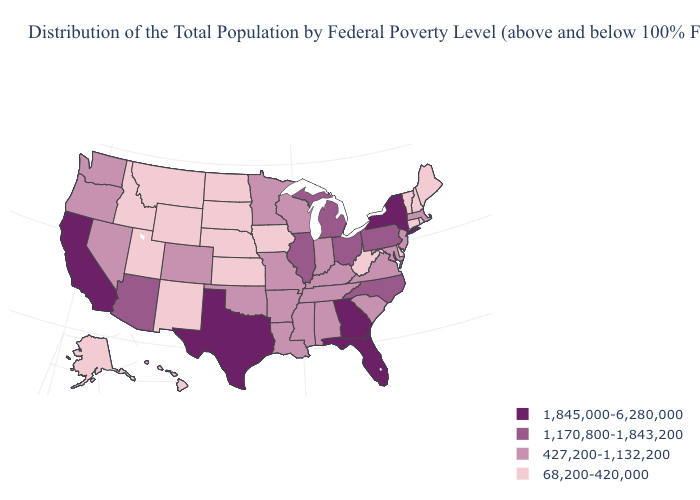Does the map have missing data?
Write a very short answer. No. Name the states that have a value in the range 1,170,800-1,843,200?
Concise answer only. Arizona, Illinois, Michigan, North Carolina, Ohio, Pennsylvania. Which states hav the highest value in the South?
Be succinct. Florida, Georgia, Texas. What is the value of Pennsylvania?
Be succinct. 1,170,800-1,843,200. What is the lowest value in the Northeast?
Concise answer only. 68,200-420,000. Among the states that border Pennsylvania , does West Virginia have the lowest value?
Give a very brief answer. Yes. What is the value of Delaware?
Keep it brief. 68,200-420,000. How many symbols are there in the legend?
Keep it brief. 4. Which states have the lowest value in the West?
Short answer required. Alaska, Hawaii, Idaho, Montana, New Mexico, Utah, Wyoming. What is the value of Arizona?
Keep it brief. 1,170,800-1,843,200. Which states have the lowest value in the Northeast?
Short answer required. Connecticut, Maine, New Hampshire, Rhode Island, Vermont. Name the states that have a value in the range 1,170,800-1,843,200?
Keep it brief. Arizona, Illinois, Michigan, North Carolina, Ohio, Pennsylvania. Is the legend a continuous bar?
Short answer required. No. What is the value of Colorado?
Quick response, please. 427,200-1,132,200. 